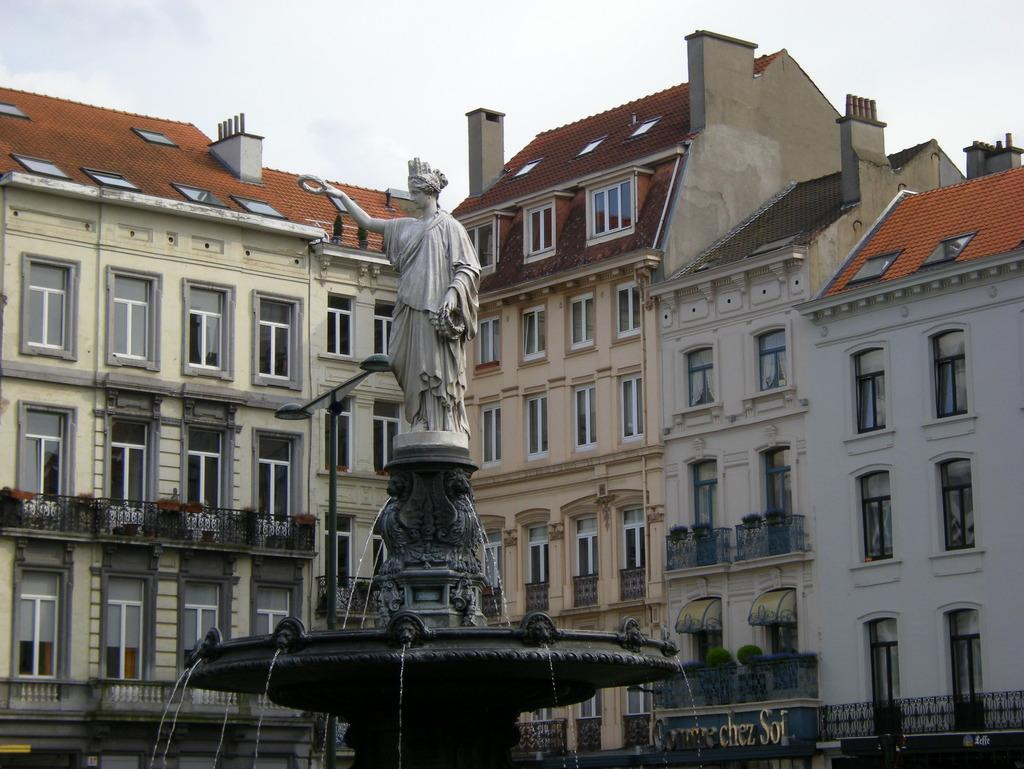What is the main subject of the image? There is a statue in the image. Where is the statue located? The statue is on a fountain. What can be seen in the background of the image? There are buildings, an electric pole with lights, and some unspecified objects in the background of the image. What is visible in the sky in the image? The sky is visible in the background of the image. What type of writer is depicted on the statue in the image? There is no writer depicted on the statue in the image; it is a statue without any specific person or character. How many selections are available for the swing in the image? There is no swing present in the image, so it is not possible to determine the number of selections available. 